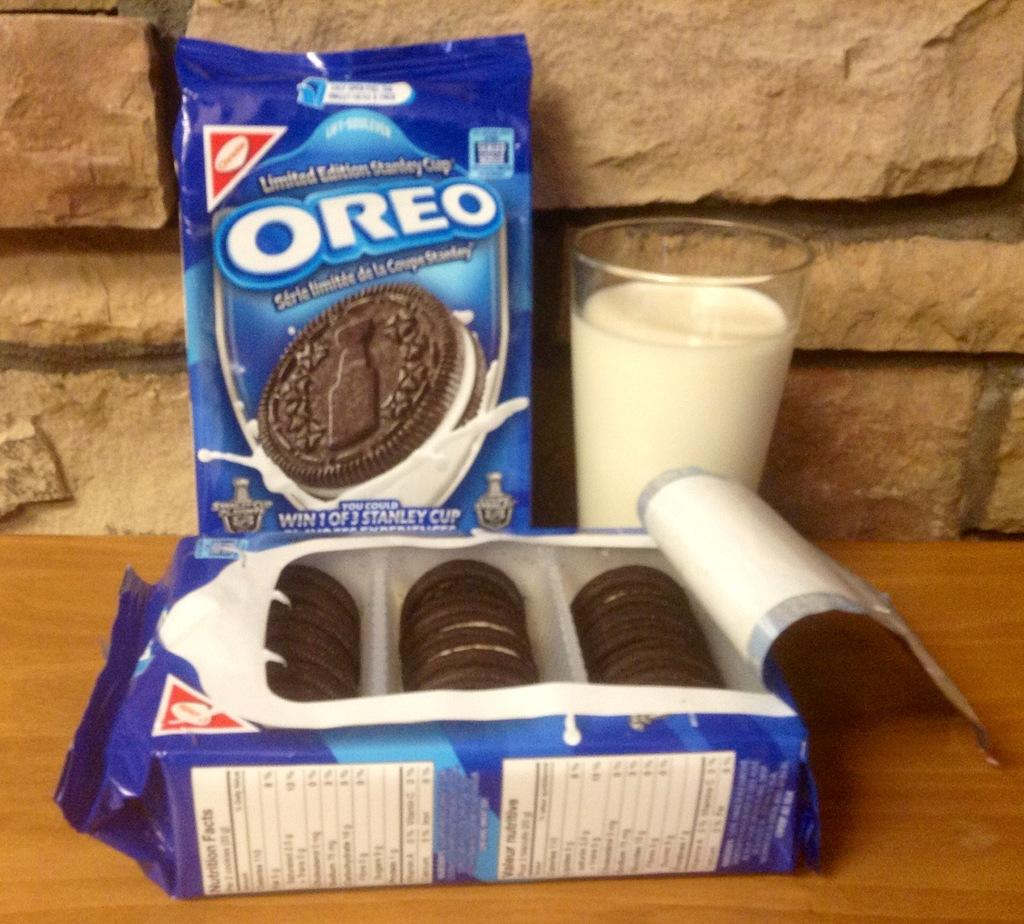What objects are present on the table in the image? There are packets and a glass with milk on the table in the image. What is inside the glass? The glass contains milk. What is the background of the image? There is a wall visible in the background of the image. What time is displayed on the clock in the image? There is no clock present in the image. How does the sponge help in cleaning the table in the image? There is no sponge present in the image, so it cannot be used for cleaning the table. 